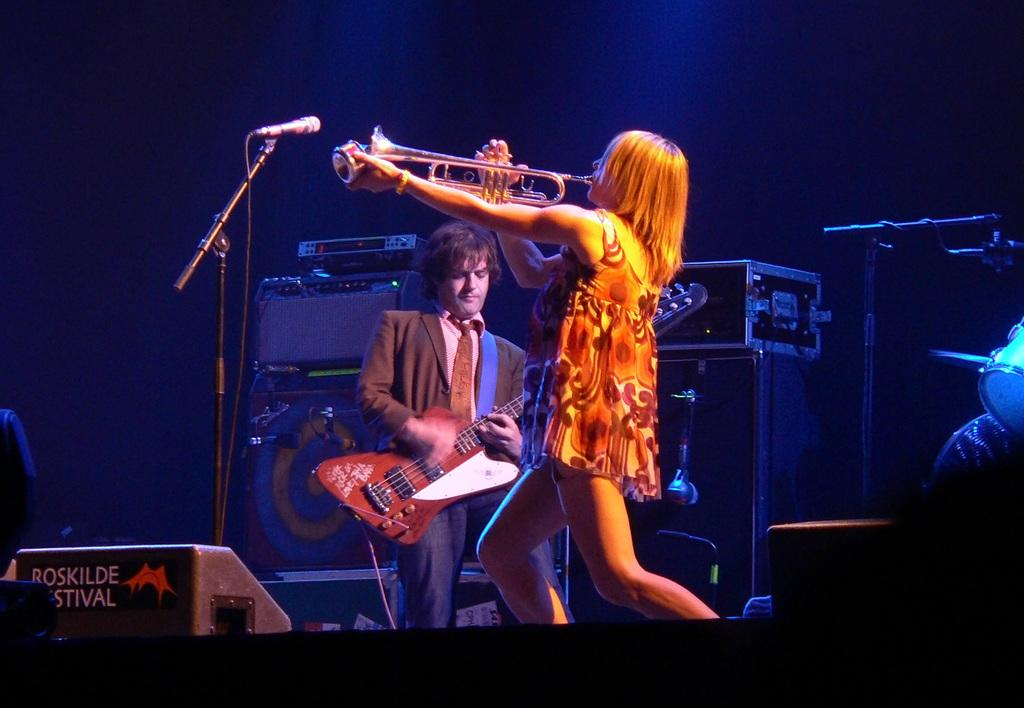How many people are in the image? There are two people in the image. What is one of the people holding? One of the people is holding a guitar. What object is present in the image that is commonly used for amplifying sound? There is a microphone in the image. What is the purpose of the copper in the image? There is no copper present in the image. Is there a band performing in the image? The image does not show a band or any indication of a performance. 